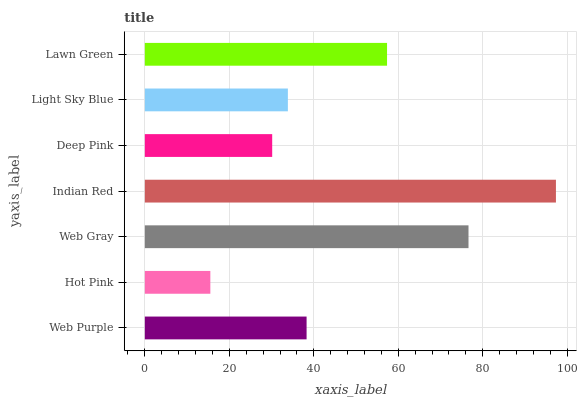Is Hot Pink the minimum?
Answer yes or no. Yes. Is Indian Red the maximum?
Answer yes or no. Yes. Is Web Gray the minimum?
Answer yes or no. No. Is Web Gray the maximum?
Answer yes or no. No. Is Web Gray greater than Hot Pink?
Answer yes or no. Yes. Is Hot Pink less than Web Gray?
Answer yes or no. Yes. Is Hot Pink greater than Web Gray?
Answer yes or no. No. Is Web Gray less than Hot Pink?
Answer yes or no. No. Is Web Purple the high median?
Answer yes or no. Yes. Is Web Purple the low median?
Answer yes or no. Yes. Is Deep Pink the high median?
Answer yes or no. No. Is Hot Pink the low median?
Answer yes or no. No. 